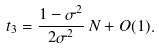<formula> <loc_0><loc_0><loc_500><loc_500>t _ { 3 } = \frac { 1 - \sigma ^ { 2 } } { 2 \sigma ^ { 2 } } \, N + O ( 1 ) .</formula> 